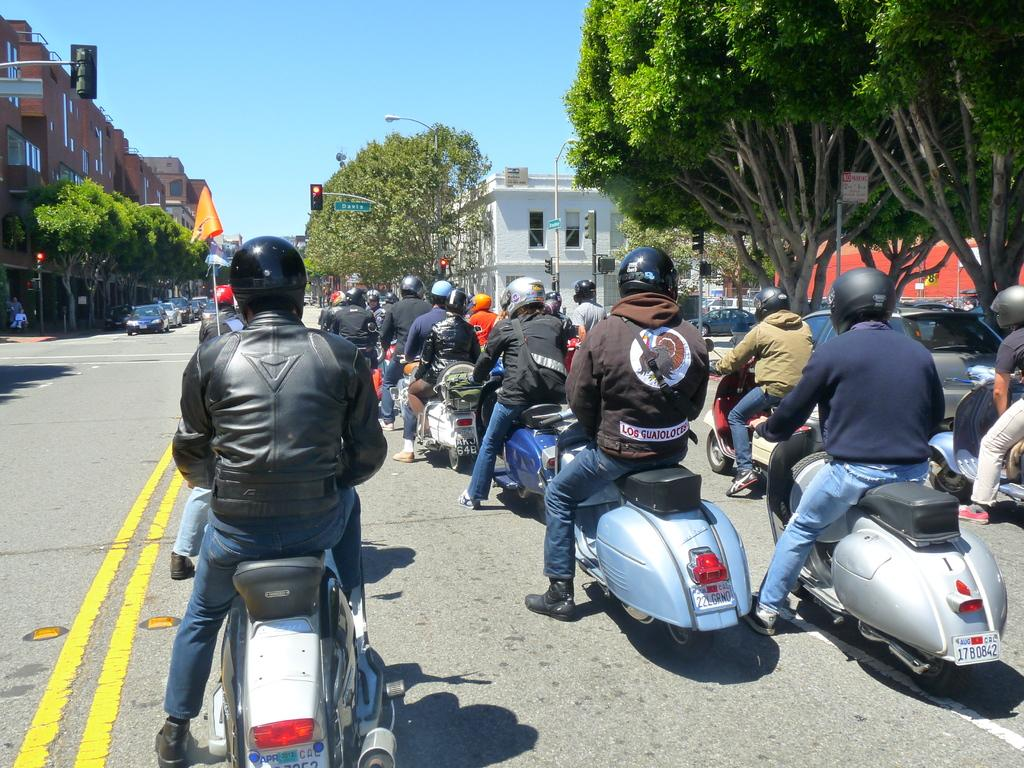How many people are on the scooter in the image? There are multiple people on the scooter in the image. What safety precaution are the people taking while riding the scooter? The people are wearing helmets. What can be seen on both sides of the image? Buildings and trees are present on both sides of the image. What type of wound can be seen on the scooter in the image? There is no wound present on the scooter or the people in the image. Where is the shelf located in the image? There is no shelf present in the image. 